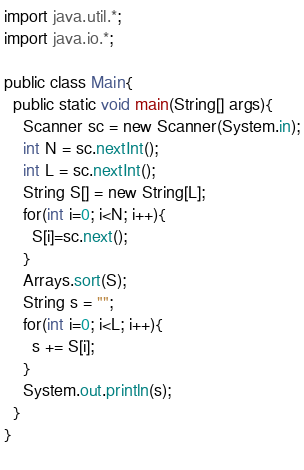<code> <loc_0><loc_0><loc_500><loc_500><_Java_>import java.util.*;
import java.io.*;

public class Main{
  public static void main(String[] args){
    Scanner sc = new Scanner(System.in);
    int N = sc.nextInt();
    int L = sc.nextInt();
    String S[] = new String[L];
    for(int i=0; i<N; i++){
      S[i]=sc.next();
    }
    Arrays.sort(S);
    String s = "";
    for(int i=0; i<L; i++){
      s += S[i];
    }
    System.out.println(s);
  }
}
      </code> 